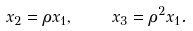<formula> <loc_0><loc_0><loc_500><loc_500>x _ { 2 } = \rho x _ { 1 } , \quad x _ { 3 } = \rho ^ { 2 } x _ { 1 } .</formula> 